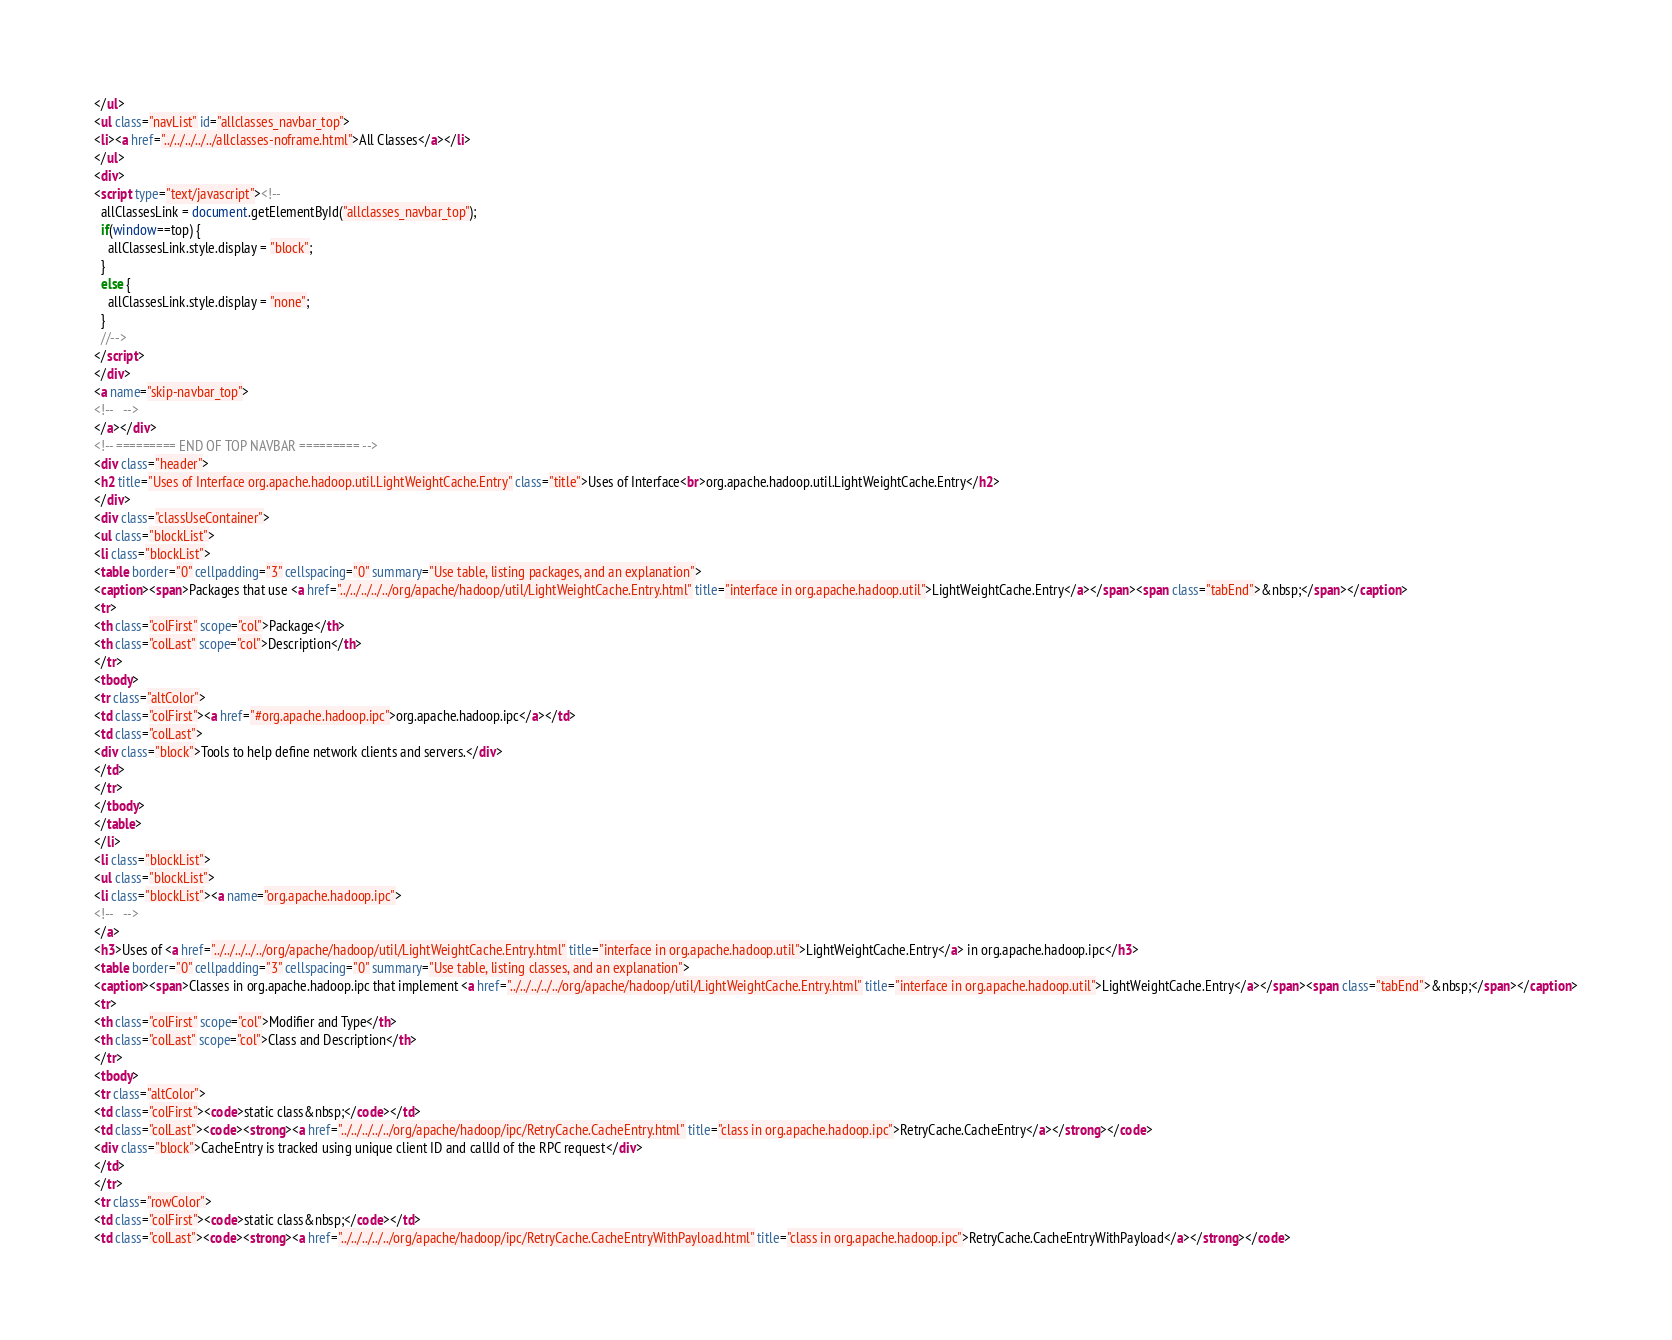Convert code to text. <code><loc_0><loc_0><loc_500><loc_500><_HTML_></ul>
<ul class="navList" id="allclasses_navbar_top">
<li><a href="../../../../../allclasses-noframe.html">All Classes</a></li>
</ul>
<div>
<script type="text/javascript"><!--
  allClassesLink = document.getElementById("allclasses_navbar_top");
  if(window==top) {
    allClassesLink.style.display = "block";
  }
  else {
    allClassesLink.style.display = "none";
  }
  //-->
</script>
</div>
<a name="skip-navbar_top">
<!--   -->
</a></div>
<!-- ========= END OF TOP NAVBAR ========= -->
<div class="header">
<h2 title="Uses of Interface org.apache.hadoop.util.LightWeightCache.Entry" class="title">Uses of Interface<br>org.apache.hadoop.util.LightWeightCache.Entry</h2>
</div>
<div class="classUseContainer">
<ul class="blockList">
<li class="blockList">
<table border="0" cellpadding="3" cellspacing="0" summary="Use table, listing packages, and an explanation">
<caption><span>Packages that use <a href="../../../../../org/apache/hadoop/util/LightWeightCache.Entry.html" title="interface in org.apache.hadoop.util">LightWeightCache.Entry</a></span><span class="tabEnd">&nbsp;</span></caption>
<tr>
<th class="colFirst" scope="col">Package</th>
<th class="colLast" scope="col">Description</th>
</tr>
<tbody>
<tr class="altColor">
<td class="colFirst"><a href="#org.apache.hadoop.ipc">org.apache.hadoop.ipc</a></td>
<td class="colLast">
<div class="block">Tools to help define network clients and servers.</div>
</td>
</tr>
</tbody>
</table>
</li>
<li class="blockList">
<ul class="blockList">
<li class="blockList"><a name="org.apache.hadoop.ipc">
<!--   -->
</a>
<h3>Uses of <a href="../../../../../org/apache/hadoop/util/LightWeightCache.Entry.html" title="interface in org.apache.hadoop.util">LightWeightCache.Entry</a> in org.apache.hadoop.ipc</h3>
<table border="0" cellpadding="3" cellspacing="0" summary="Use table, listing classes, and an explanation">
<caption><span>Classes in org.apache.hadoop.ipc that implement <a href="../../../../../org/apache/hadoop/util/LightWeightCache.Entry.html" title="interface in org.apache.hadoop.util">LightWeightCache.Entry</a></span><span class="tabEnd">&nbsp;</span></caption>
<tr>
<th class="colFirst" scope="col">Modifier and Type</th>
<th class="colLast" scope="col">Class and Description</th>
</tr>
<tbody>
<tr class="altColor">
<td class="colFirst"><code>static class&nbsp;</code></td>
<td class="colLast"><code><strong><a href="../../../../../org/apache/hadoop/ipc/RetryCache.CacheEntry.html" title="class in org.apache.hadoop.ipc">RetryCache.CacheEntry</a></strong></code>
<div class="block">CacheEntry is tracked using unique client ID and callId of the RPC request</div>
</td>
</tr>
<tr class="rowColor">
<td class="colFirst"><code>static class&nbsp;</code></td>
<td class="colLast"><code><strong><a href="../../../../../org/apache/hadoop/ipc/RetryCache.CacheEntryWithPayload.html" title="class in org.apache.hadoop.ipc">RetryCache.CacheEntryWithPayload</a></strong></code></code> 